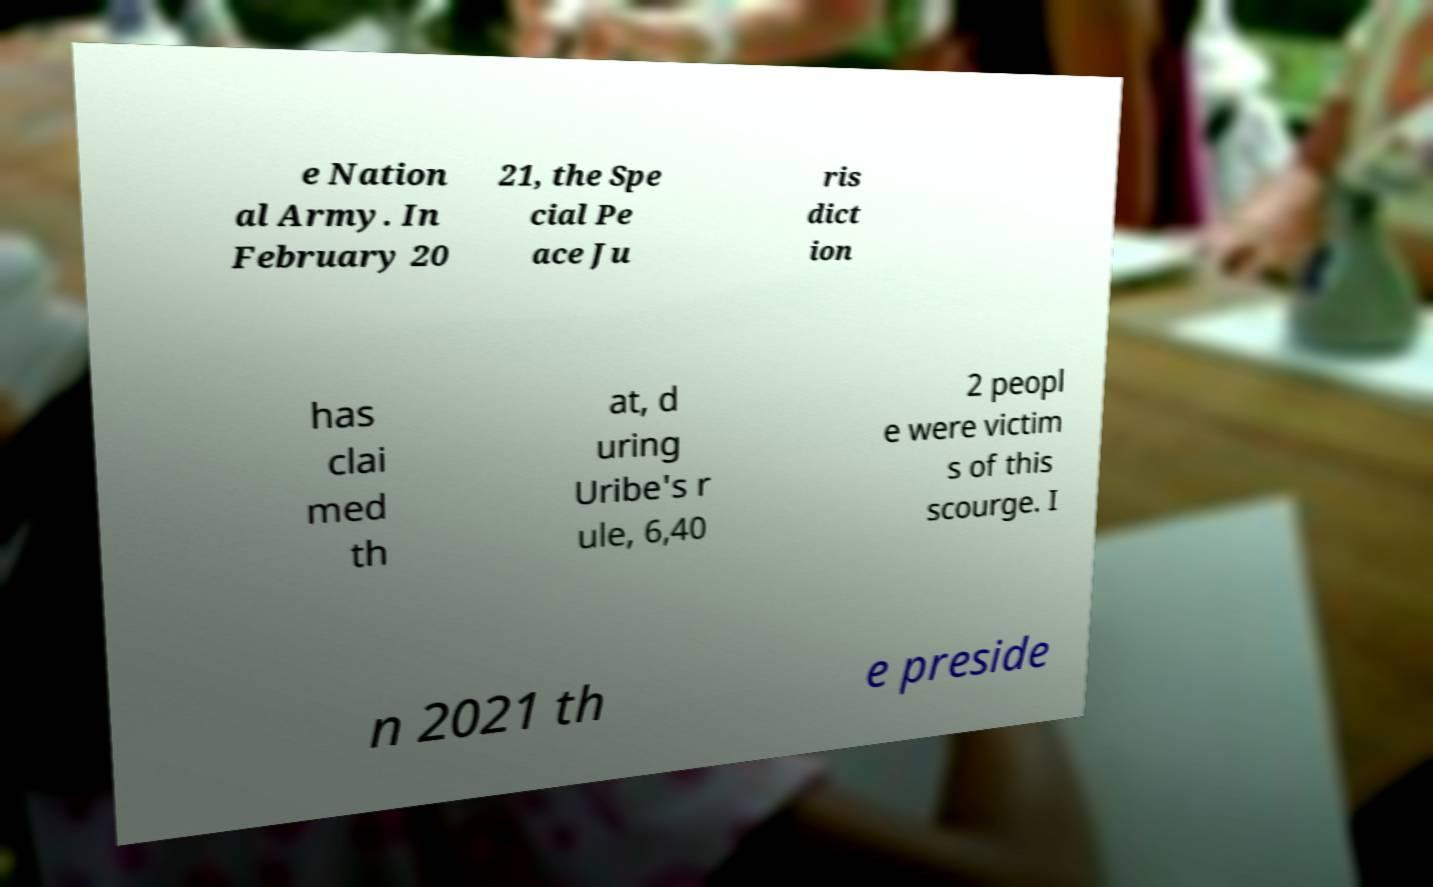What messages or text are displayed in this image? I need them in a readable, typed format. e Nation al Army. In February 20 21, the Spe cial Pe ace Ju ris dict ion has clai med th at, d uring Uribe's r ule, 6,40 2 peopl e were victim s of this scourge. I n 2021 th e preside 